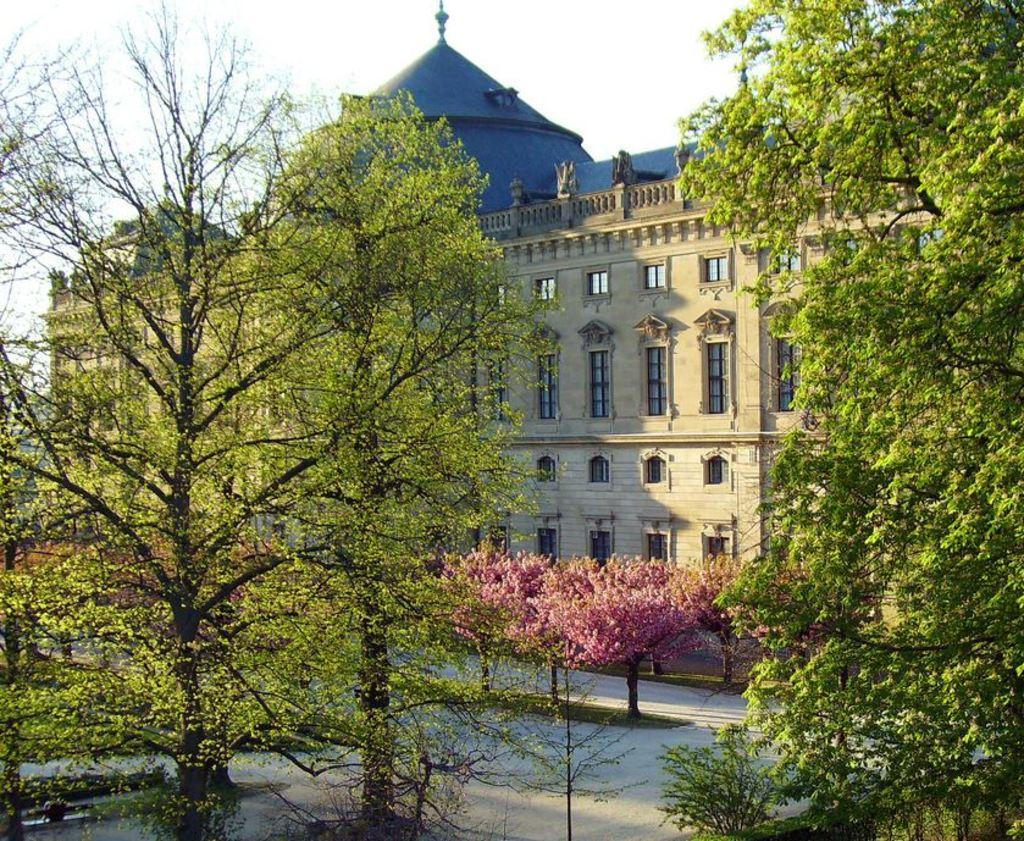What type of natural elements can be seen in the image? There are trees in the image. What type of man-made structure is visible in the background? There is a building in the background of the image. What part of the natural environment is visible in the image? The sky is visible at the top of the image. What feature of the building can be seen in the image? Windows of the building are visible in the image. What hobbies are the trees in the image engaged in? Trees do not have hobbies, as they are inanimate objects. Can you see an airplane flying in the sky in the image? There is no airplane visible in the image; only trees, a building, and the sky are present. 